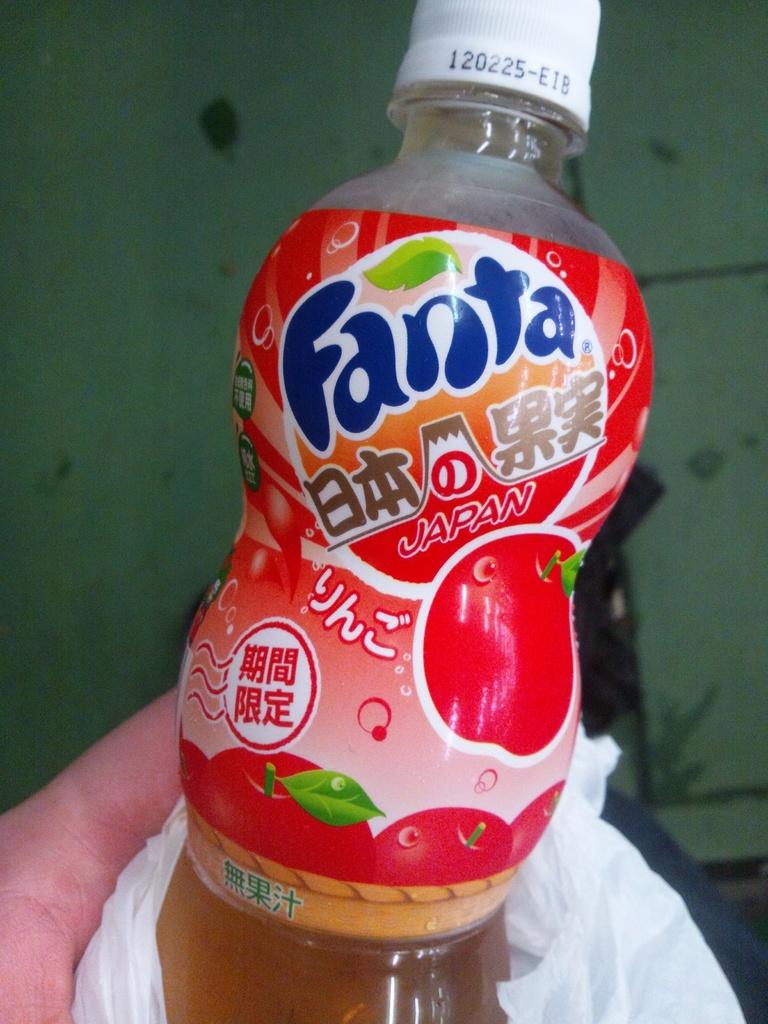Provide a one-sentence caption for the provided image. A person is holding a bottle of Fanta Japan. 